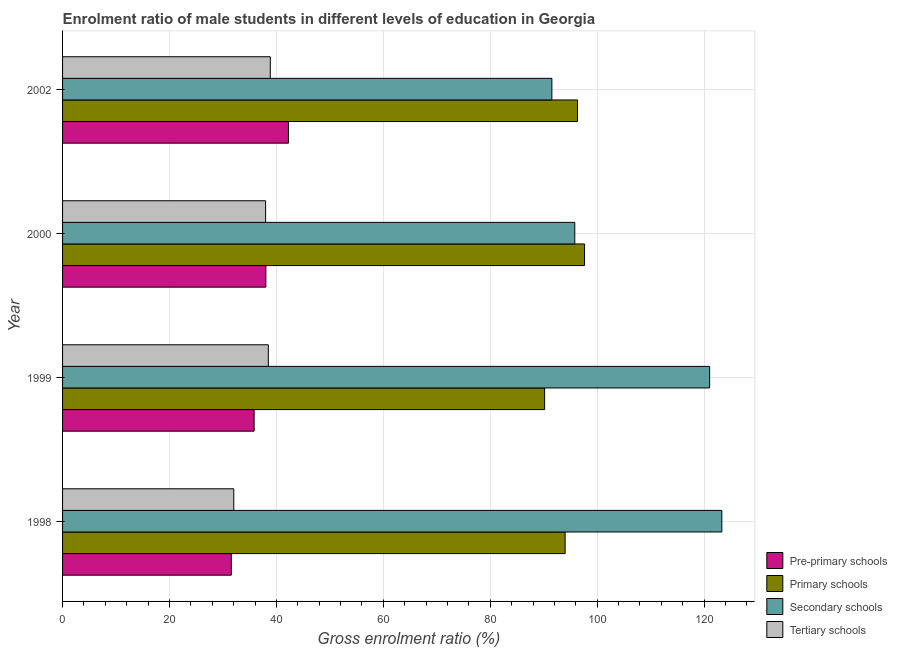How many bars are there on the 2nd tick from the top?
Make the answer very short. 4. How many bars are there on the 2nd tick from the bottom?
Keep it short and to the point. 4. What is the label of the 1st group of bars from the top?
Ensure brevity in your answer.  2002. In how many cases, is the number of bars for a given year not equal to the number of legend labels?
Provide a succinct answer. 0. What is the gross enrolment ratio(female) in secondary schools in 2000?
Provide a succinct answer. 95.81. Across all years, what is the maximum gross enrolment ratio(female) in primary schools?
Offer a terse response. 97.64. Across all years, what is the minimum gross enrolment ratio(female) in primary schools?
Make the answer very short. 90.17. In which year was the gross enrolment ratio(female) in pre-primary schools maximum?
Keep it short and to the point. 2002. What is the total gross enrolment ratio(female) in pre-primary schools in the graph?
Provide a succinct answer. 147.67. What is the difference between the gross enrolment ratio(female) in pre-primary schools in 1998 and that in 1999?
Your response must be concise. -4.27. What is the difference between the gross enrolment ratio(female) in secondary schools in 1999 and the gross enrolment ratio(female) in pre-primary schools in 1998?
Your answer should be very brief. 89.47. What is the average gross enrolment ratio(female) in tertiary schools per year?
Ensure brevity in your answer.  36.84. In the year 2002, what is the difference between the gross enrolment ratio(female) in secondary schools and gross enrolment ratio(female) in primary schools?
Keep it short and to the point. -4.8. In how many years, is the gross enrolment ratio(female) in tertiary schools greater than 20 %?
Ensure brevity in your answer.  4. What is the ratio of the gross enrolment ratio(female) in secondary schools in 1999 to that in 2000?
Provide a succinct answer. 1.26. Is the gross enrolment ratio(female) in pre-primary schools in 1999 less than that in 2000?
Your answer should be compact. Yes. What is the difference between the highest and the second highest gross enrolment ratio(female) in primary schools?
Your answer should be compact. 1.32. What is the difference between the highest and the lowest gross enrolment ratio(female) in tertiary schools?
Ensure brevity in your answer.  6.83. In how many years, is the gross enrolment ratio(female) in tertiary schools greater than the average gross enrolment ratio(female) in tertiary schools taken over all years?
Provide a short and direct response. 3. Is it the case that in every year, the sum of the gross enrolment ratio(female) in pre-primary schools and gross enrolment ratio(female) in primary schools is greater than the sum of gross enrolment ratio(female) in secondary schools and gross enrolment ratio(female) in tertiary schools?
Provide a short and direct response. Yes. What does the 3rd bar from the top in 2002 represents?
Provide a short and direct response. Primary schools. What does the 2nd bar from the bottom in 2000 represents?
Provide a short and direct response. Primary schools. How many bars are there?
Keep it short and to the point. 16. Are all the bars in the graph horizontal?
Offer a very short reply. Yes. How many years are there in the graph?
Offer a very short reply. 4. What is the difference between two consecutive major ticks on the X-axis?
Make the answer very short. 20. Does the graph contain grids?
Your response must be concise. Yes. How many legend labels are there?
Make the answer very short. 4. How are the legend labels stacked?
Make the answer very short. Vertical. What is the title of the graph?
Make the answer very short. Enrolment ratio of male students in different levels of education in Georgia. What is the label or title of the Y-axis?
Offer a terse response. Year. What is the Gross enrolment ratio (%) of Pre-primary schools in 1998?
Ensure brevity in your answer.  31.56. What is the Gross enrolment ratio (%) in Primary schools in 1998?
Provide a succinct answer. 94. What is the Gross enrolment ratio (%) of Secondary schools in 1998?
Offer a very short reply. 123.32. What is the Gross enrolment ratio (%) of Tertiary schools in 1998?
Offer a terse response. 32.03. What is the Gross enrolment ratio (%) of Pre-primary schools in 1999?
Offer a terse response. 35.83. What is the Gross enrolment ratio (%) of Primary schools in 1999?
Offer a very short reply. 90.17. What is the Gross enrolment ratio (%) of Secondary schools in 1999?
Give a very brief answer. 121.03. What is the Gross enrolment ratio (%) of Tertiary schools in 1999?
Give a very brief answer. 38.49. What is the Gross enrolment ratio (%) in Pre-primary schools in 2000?
Provide a short and direct response. 38.03. What is the Gross enrolment ratio (%) of Primary schools in 2000?
Keep it short and to the point. 97.64. What is the Gross enrolment ratio (%) in Secondary schools in 2000?
Your answer should be compact. 95.81. What is the Gross enrolment ratio (%) in Tertiary schools in 2000?
Keep it short and to the point. 37.98. What is the Gross enrolment ratio (%) in Pre-primary schools in 2002?
Your answer should be very brief. 42.26. What is the Gross enrolment ratio (%) in Primary schools in 2002?
Ensure brevity in your answer.  96.32. What is the Gross enrolment ratio (%) in Secondary schools in 2002?
Ensure brevity in your answer.  91.52. What is the Gross enrolment ratio (%) in Tertiary schools in 2002?
Provide a short and direct response. 38.85. Across all years, what is the maximum Gross enrolment ratio (%) in Pre-primary schools?
Provide a short and direct response. 42.26. Across all years, what is the maximum Gross enrolment ratio (%) of Primary schools?
Your response must be concise. 97.64. Across all years, what is the maximum Gross enrolment ratio (%) of Secondary schools?
Keep it short and to the point. 123.32. Across all years, what is the maximum Gross enrolment ratio (%) in Tertiary schools?
Make the answer very short. 38.85. Across all years, what is the minimum Gross enrolment ratio (%) of Pre-primary schools?
Your answer should be very brief. 31.56. Across all years, what is the minimum Gross enrolment ratio (%) in Primary schools?
Keep it short and to the point. 90.17. Across all years, what is the minimum Gross enrolment ratio (%) in Secondary schools?
Make the answer very short. 91.52. Across all years, what is the minimum Gross enrolment ratio (%) of Tertiary schools?
Your answer should be very brief. 32.03. What is the total Gross enrolment ratio (%) in Pre-primary schools in the graph?
Offer a terse response. 147.67. What is the total Gross enrolment ratio (%) in Primary schools in the graph?
Give a very brief answer. 378.13. What is the total Gross enrolment ratio (%) of Secondary schools in the graph?
Provide a short and direct response. 431.68. What is the total Gross enrolment ratio (%) in Tertiary schools in the graph?
Give a very brief answer. 147.34. What is the difference between the Gross enrolment ratio (%) of Pre-primary schools in 1998 and that in 1999?
Your answer should be very brief. -4.27. What is the difference between the Gross enrolment ratio (%) of Primary schools in 1998 and that in 1999?
Ensure brevity in your answer.  3.83. What is the difference between the Gross enrolment ratio (%) in Secondary schools in 1998 and that in 1999?
Your answer should be very brief. 2.28. What is the difference between the Gross enrolment ratio (%) of Tertiary schools in 1998 and that in 1999?
Your answer should be compact. -6.46. What is the difference between the Gross enrolment ratio (%) of Pre-primary schools in 1998 and that in 2000?
Offer a very short reply. -6.47. What is the difference between the Gross enrolment ratio (%) in Primary schools in 1998 and that in 2000?
Your response must be concise. -3.63. What is the difference between the Gross enrolment ratio (%) of Secondary schools in 1998 and that in 2000?
Make the answer very short. 27.51. What is the difference between the Gross enrolment ratio (%) of Tertiary schools in 1998 and that in 2000?
Ensure brevity in your answer.  -5.95. What is the difference between the Gross enrolment ratio (%) in Pre-primary schools in 1998 and that in 2002?
Keep it short and to the point. -10.7. What is the difference between the Gross enrolment ratio (%) in Primary schools in 1998 and that in 2002?
Your answer should be very brief. -2.32. What is the difference between the Gross enrolment ratio (%) in Secondary schools in 1998 and that in 2002?
Your answer should be very brief. 31.79. What is the difference between the Gross enrolment ratio (%) in Tertiary schools in 1998 and that in 2002?
Keep it short and to the point. -6.83. What is the difference between the Gross enrolment ratio (%) in Pre-primary schools in 1999 and that in 2000?
Keep it short and to the point. -2.2. What is the difference between the Gross enrolment ratio (%) in Primary schools in 1999 and that in 2000?
Keep it short and to the point. -7.47. What is the difference between the Gross enrolment ratio (%) in Secondary schools in 1999 and that in 2000?
Keep it short and to the point. 25.22. What is the difference between the Gross enrolment ratio (%) in Tertiary schools in 1999 and that in 2000?
Your answer should be compact. 0.51. What is the difference between the Gross enrolment ratio (%) of Pre-primary schools in 1999 and that in 2002?
Make the answer very short. -6.43. What is the difference between the Gross enrolment ratio (%) in Primary schools in 1999 and that in 2002?
Keep it short and to the point. -6.15. What is the difference between the Gross enrolment ratio (%) of Secondary schools in 1999 and that in 2002?
Ensure brevity in your answer.  29.51. What is the difference between the Gross enrolment ratio (%) of Tertiary schools in 1999 and that in 2002?
Keep it short and to the point. -0.37. What is the difference between the Gross enrolment ratio (%) of Pre-primary schools in 2000 and that in 2002?
Keep it short and to the point. -4.23. What is the difference between the Gross enrolment ratio (%) of Primary schools in 2000 and that in 2002?
Make the answer very short. 1.32. What is the difference between the Gross enrolment ratio (%) of Secondary schools in 2000 and that in 2002?
Your answer should be compact. 4.28. What is the difference between the Gross enrolment ratio (%) of Tertiary schools in 2000 and that in 2002?
Offer a terse response. -0.88. What is the difference between the Gross enrolment ratio (%) of Pre-primary schools in 1998 and the Gross enrolment ratio (%) of Primary schools in 1999?
Keep it short and to the point. -58.61. What is the difference between the Gross enrolment ratio (%) in Pre-primary schools in 1998 and the Gross enrolment ratio (%) in Secondary schools in 1999?
Ensure brevity in your answer.  -89.47. What is the difference between the Gross enrolment ratio (%) of Pre-primary schools in 1998 and the Gross enrolment ratio (%) of Tertiary schools in 1999?
Make the answer very short. -6.92. What is the difference between the Gross enrolment ratio (%) in Primary schools in 1998 and the Gross enrolment ratio (%) in Secondary schools in 1999?
Your answer should be compact. -27.03. What is the difference between the Gross enrolment ratio (%) of Primary schools in 1998 and the Gross enrolment ratio (%) of Tertiary schools in 1999?
Give a very brief answer. 55.52. What is the difference between the Gross enrolment ratio (%) in Secondary schools in 1998 and the Gross enrolment ratio (%) in Tertiary schools in 1999?
Your answer should be compact. 84.83. What is the difference between the Gross enrolment ratio (%) in Pre-primary schools in 1998 and the Gross enrolment ratio (%) in Primary schools in 2000?
Provide a succinct answer. -66.08. What is the difference between the Gross enrolment ratio (%) of Pre-primary schools in 1998 and the Gross enrolment ratio (%) of Secondary schools in 2000?
Offer a very short reply. -64.25. What is the difference between the Gross enrolment ratio (%) in Pre-primary schools in 1998 and the Gross enrolment ratio (%) in Tertiary schools in 2000?
Your answer should be very brief. -6.42. What is the difference between the Gross enrolment ratio (%) in Primary schools in 1998 and the Gross enrolment ratio (%) in Secondary schools in 2000?
Your answer should be very brief. -1.81. What is the difference between the Gross enrolment ratio (%) of Primary schools in 1998 and the Gross enrolment ratio (%) of Tertiary schools in 2000?
Your answer should be compact. 56.02. What is the difference between the Gross enrolment ratio (%) of Secondary schools in 1998 and the Gross enrolment ratio (%) of Tertiary schools in 2000?
Your answer should be compact. 85.34. What is the difference between the Gross enrolment ratio (%) in Pre-primary schools in 1998 and the Gross enrolment ratio (%) in Primary schools in 2002?
Ensure brevity in your answer.  -64.76. What is the difference between the Gross enrolment ratio (%) of Pre-primary schools in 1998 and the Gross enrolment ratio (%) of Secondary schools in 2002?
Your answer should be compact. -59.96. What is the difference between the Gross enrolment ratio (%) in Pre-primary schools in 1998 and the Gross enrolment ratio (%) in Tertiary schools in 2002?
Provide a succinct answer. -7.29. What is the difference between the Gross enrolment ratio (%) of Primary schools in 1998 and the Gross enrolment ratio (%) of Secondary schools in 2002?
Offer a terse response. 2.48. What is the difference between the Gross enrolment ratio (%) of Primary schools in 1998 and the Gross enrolment ratio (%) of Tertiary schools in 2002?
Your response must be concise. 55.15. What is the difference between the Gross enrolment ratio (%) of Secondary schools in 1998 and the Gross enrolment ratio (%) of Tertiary schools in 2002?
Keep it short and to the point. 84.46. What is the difference between the Gross enrolment ratio (%) in Pre-primary schools in 1999 and the Gross enrolment ratio (%) in Primary schools in 2000?
Keep it short and to the point. -61.81. What is the difference between the Gross enrolment ratio (%) in Pre-primary schools in 1999 and the Gross enrolment ratio (%) in Secondary schools in 2000?
Your answer should be compact. -59.98. What is the difference between the Gross enrolment ratio (%) in Pre-primary schools in 1999 and the Gross enrolment ratio (%) in Tertiary schools in 2000?
Make the answer very short. -2.15. What is the difference between the Gross enrolment ratio (%) in Primary schools in 1999 and the Gross enrolment ratio (%) in Secondary schools in 2000?
Keep it short and to the point. -5.64. What is the difference between the Gross enrolment ratio (%) of Primary schools in 1999 and the Gross enrolment ratio (%) of Tertiary schools in 2000?
Your response must be concise. 52.19. What is the difference between the Gross enrolment ratio (%) in Secondary schools in 1999 and the Gross enrolment ratio (%) in Tertiary schools in 2000?
Provide a succinct answer. 83.06. What is the difference between the Gross enrolment ratio (%) of Pre-primary schools in 1999 and the Gross enrolment ratio (%) of Primary schools in 2002?
Offer a terse response. -60.49. What is the difference between the Gross enrolment ratio (%) of Pre-primary schools in 1999 and the Gross enrolment ratio (%) of Secondary schools in 2002?
Keep it short and to the point. -55.7. What is the difference between the Gross enrolment ratio (%) in Pre-primary schools in 1999 and the Gross enrolment ratio (%) in Tertiary schools in 2002?
Ensure brevity in your answer.  -3.03. What is the difference between the Gross enrolment ratio (%) of Primary schools in 1999 and the Gross enrolment ratio (%) of Secondary schools in 2002?
Provide a short and direct response. -1.35. What is the difference between the Gross enrolment ratio (%) of Primary schools in 1999 and the Gross enrolment ratio (%) of Tertiary schools in 2002?
Offer a terse response. 51.31. What is the difference between the Gross enrolment ratio (%) in Secondary schools in 1999 and the Gross enrolment ratio (%) in Tertiary schools in 2002?
Ensure brevity in your answer.  82.18. What is the difference between the Gross enrolment ratio (%) in Pre-primary schools in 2000 and the Gross enrolment ratio (%) in Primary schools in 2002?
Your answer should be compact. -58.29. What is the difference between the Gross enrolment ratio (%) in Pre-primary schools in 2000 and the Gross enrolment ratio (%) in Secondary schools in 2002?
Your answer should be very brief. -53.49. What is the difference between the Gross enrolment ratio (%) of Pre-primary schools in 2000 and the Gross enrolment ratio (%) of Tertiary schools in 2002?
Your answer should be very brief. -0.83. What is the difference between the Gross enrolment ratio (%) of Primary schools in 2000 and the Gross enrolment ratio (%) of Secondary schools in 2002?
Provide a succinct answer. 6.11. What is the difference between the Gross enrolment ratio (%) in Primary schools in 2000 and the Gross enrolment ratio (%) in Tertiary schools in 2002?
Offer a terse response. 58.78. What is the difference between the Gross enrolment ratio (%) of Secondary schools in 2000 and the Gross enrolment ratio (%) of Tertiary schools in 2002?
Your response must be concise. 56.95. What is the average Gross enrolment ratio (%) of Pre-primary schools per year?
Provide a short and direct response. 36.92. What is the average Gross enrolment ratio (%) of Primary schools per year?
Offer a very short reply. 94.53. What is the average Gross enrolment ratio (%) of Secondary schools per year?
Your answer should be compact. 107.92. What is the average Gross enrolment ratio (%) of Tertiary schools per year?
Make the answer very short. 36.84. In the year 1998, what is the difference between the Gross enrolment ratio (%) of Pre-primary schools and Gross enrolment ratio (%) of Primary schools?
Offer a terse response. -62.44. In the year 1998, what is the difference between the Gross enrolment ratio (%) of Pre-primary schools and Gross enrolment ratio (%) of Secondary schools?
Provide a succinct answer. -91.76. In the year 1998, what is the difference between the Gross enrolment ratio (%) in Pre-primary schools and Gross enrolment ratio (%) in Tertiary schools?
Keep it short and to the point. -0.47. In the year 1998, what is the difference between the Gross enrolment ratio (%) of Primary schools and Gross enrolment ratio (%) of Secondary schools?
Give a very brief answer. -29.31. In the year 1998, what is the difference between the Gross enrolment ratio (%) in Primary schools and Gross enrolment ratio (%) in Tertiary schools?
Provide a short and direct response. 61.98. In the year 1998, what is the difference between the Gross enrolment ratio (%) of Secondary schools and Gross enrolment ratio (%) of Tertiary schools?
Offer a very short reply. 91.29. In the year 1999, what is the difference between the Gross enrolment ratio (%) of Pre-primary schools and Gross enrolment ratio (%) of Primary schools?
Provide a succinct answer. -54.34. In the year 1999, what is the difference between the Gross enrolment ratio (%) in Pre-primary schools and Gross enrolment ratio (%) in Secondary schools?
Give a very brief answer. -85.2. In the year 1999, what is the difference between the Gross enrolment ratio (%) of Pre-primary schools and Gross enrolment ratio (%) of Tertiary schools?
Offer a terse response. -2.66. In the year 1999, what is the difference between the Gross enrolment ratio (%) in Primary schools and Gross enrolment ratio (%) in Secondary schools?
Give a very brief answer. -30.86. In the year 1999, what is the difference between the Gross enrolment ratio (%) of Primary schools and Gross enrolment ratio (%) of Tertiary schools?
Make the answer very short. 51.68. In the year 1999, what is the difference between the Gross enrolment ratio (%) of Secondary schools and Gross enrolment ratio (%) of Tertiary schools?
Provide a succinct answer. 82.55. In the year 2000, what is the difference between the Gross enrolment ratio (%) in Pre-primary schools and Gross enrolment ratio (%) in Primary schools?
Offer a very short reply. -59.61. In the year 2000, what is the difference between the Gross enrolment ratio (%) in Pre-primary schools and Gross enrolment ratio (%) in Secondary schools?
Provide a short and direct response. -57.78. In the year 2000, what is the difference between the Gross enrolment ratio (%) of Pre-primary schools and Gross enrolment ratio (%) of Tertiary schools?
Your answer should be very brief. 0.05. In the year 2000, what is the difference between the Gross enrolment ratio (%) in Primary schools and Gross enrolment ratio (%) in Secondary schools?
Your response must be concise. 1.83. In the year 2000, what is the difference between the Gross enrolment ratio (%) in Primary schools and Gross enrolment ratio (%) in Tertiary schools?
Your answer should be compact. 59.66. In the year 2000, what is the difference between the Gross enrolment ratio (%) of Secondary schools and Gross enrolment ratio (%) of Tertiary schools?
Your answer should be compact. 57.83. In the year 2002, what is the difference between the Gross enrolment ratio (%) in Pre-primary schools and Gross enrolment ratio (%) in Primary schools?
Your answer should be very brief. -54.06. In the year 2002, what is the difference between the Gross enrolment ratio (%) of Pre-primary schools and Gross enrolment ratio (%) of Secondary schools?
Your response must be concise. -49.27. In the year 2002, what is the difference between the Gross enrolment ratio (%) in Pre-primary schools and Gross enrolment ratio (%) in Tertiary schools?
Make the answer very short. 3.4. In the year 2002, what is the difference between the Gross enrolment ratio (%) in Primary schools and Gross enrolment ratio (%) in Secondary schools?
Offer a terse response. 4.8. In the year 2002, what is the difference between the Gross enrolment ratio (%) in Primary schools and Gross enrolment ratio (%) in Tertiary schools?
Your answer should be compact. 57.47. In the year 2002, what is the difference between the Gross enrolment ratio (%) in Secondary schools and Gross enrolment ratio (%) in Tertiary schools?
Make the answer very short. 52.67. What is the ratio of the Gross enrolment ratio (%) in Pre-primary schools in 1998 to that in 1999?
Ensure brevity in your answer.  0.88. What is the ratio of the Gross enrolment ratio (%) of Primary schools in 1998 to that in 1999?
Make the answer very short. 1.04. What is the ratio of the Gross enrolment ratio (%) in Secondary schools in 1998 to that in 1999?
Your response must be concise. 1.02. What is the ratio of the Gross enrolment ratio (%) in Tertiary schools in 1998 to that in 1999?
Provide a succinct answer. 0.83. What is the ratio of the Gross enrolment ratio (%) of Pre-primary schools in 1998 to that in 2000?
Give a very brief answer. 0.83. What is the ratio of the Gross enrolment ratio (%) in Primary schools in 1998 to that in 2000?
Keep it short and to the point. 0.96. What is the ratio of the Gross enrolment ratio (%) in Secondary schools in 1998 to that in 2000?
Make the answer very short. 1.29. What is the ratio of the Gross enrolment ratio (%) of Tertiary schools in 1998 to that in 2000?
Keep it short and to the point. 0.84. What is the ratio of the Gross enrolment ratio (%) of Pre-primary schools in 1998 to that in 2002?
Ensure brevity in your answer.  0.75. What is the ratio of the Gross enrolment ratio (%) of Primary schools in 1998 to that in 2002?
Offer a very short reply. 0.98. What is the ratio of the Gross enrolment ratio (%) of Secondary schools in 1998 to that in 2002?
Keep it short and to the point. 1.35. What is the ratio of the Gross enrolment ratio (%) in Tertiary schools in 1998 to that in 2002?
Your answer should be very brief. 0.82. What is the ratio of the Gross enrolment ratio (%) in Pre-primary schools in 1999 to that in 2000?
Make the answer very short. 0.94. What is the ratio of the Gross enrolment ratio (%) in Primary schools in 1999 to that in 2000?
Ensure brevity in your answer.  0.92. What is the ratio of the Gross enrolment ratio (%) in Secondary schools in 1999 to that in 2000?
Ensure brevity in your answer.  1.26. What is the ratio of the Gross enrolment ratio (%) of Tertiary schools in 1999 to that in 2000?
Make the answer very short. 1.01. What is the ratio of the Gross enrolment ratio (%) of Pre-primary schools in 1999 to that in 2002?
Ensure brevity in your answer.  0.85. What is the ratio of the Gross enrolment ratio (%) in Primary schools in 1999 to that in 2002?
Offer a very short reply. 0.94. What is the ratio of the Gross enrolment ratio (%) of Secondary schools in 1999 to that in 2002?
Your answer should be compact. 1.32. What is the ratio of the Gross enrolment ratio (%) of Tertiary schools in 1999 to that in 2002?
Offer a very short reply. 0.99. What is the ratio of the Gross enrolment ratio (%) of Primary schools in 2000 to that in 2002?
Keep it short and to the point. 1.01. What is the ratio of the Gross enrolment ratio (%) in Secondary schools in 2000 to that in 2002?
Provide a succinct answer. 1.05. What is the ratio of the Gross enrolment ratio (%) in Tertiary schools in 2000 to that in 2002?
Provide a short and direct response. 0.98. What is the difference between the highest and the second highest Gross enrolment ratio (%) of Pre-primary schools?
Ensure brevity in your answer.  4.23. What is the difference between the highest and the second highest Gross enrolment ratio (%) of Primary schools?
Provide a short and direct response. 1.32. What is the difference between the highest and the second highest Gross enrolment ratio (%) of Secondary schools?
Your response must be concise. 2.28. What is the difference between the highest and the second highest Gross enrolment ratio (%) in Tertiary schools?
Provide a short and direct response. 0.37. What is the difference between the highest and the lowest Gross enrolment ratio (%) of Pre-primary schools?
Ensure brevity in your answer.  10.7. What is the difference between the highest and the lowest Gross enrolment ratio (%) of Primary schools?
Your answer should be very brief. 7.47. What is the difference between the highest and the lowest Gross enrolment ratio (%) of Secondary schools?
Provide a succinct answer. 31.79. What is the difference between the highest and the lowest Gross enrolment ratio (%) in Tertiary schools?
Your answer should be compact. 6.83. 